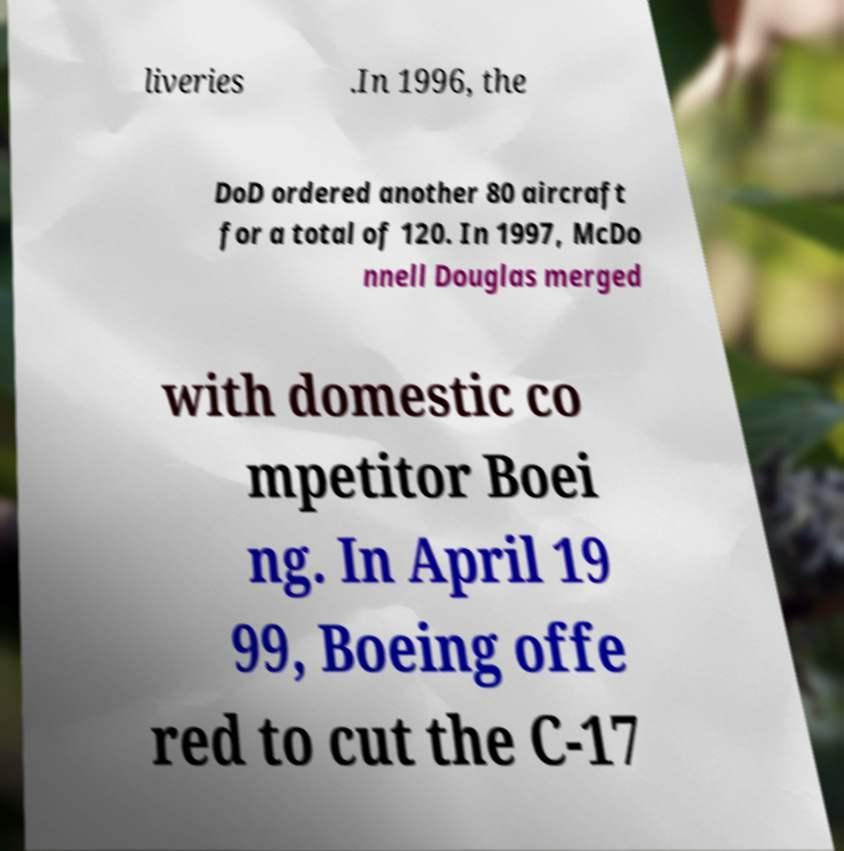There's text embedded in this image that I need extracted. Can you transcribe it verbatim? liveries .In 1996, the DoD ordered another 80 aircraft for a total of 120. In 1997, McDo nnell Douglas merged with domestic co mpetitor Boei ng. In April 19 99, Boeing offe red to cut the C-17 